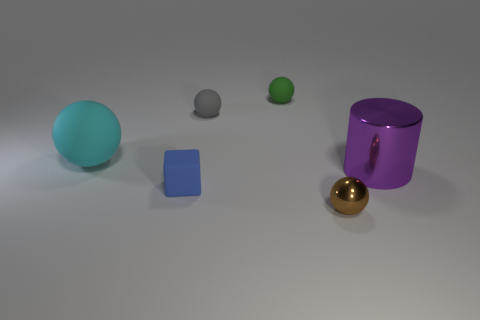Subtract all large spheres. How many spheres are left? 3 Add 2 yellow shiny blocks. How many objects exist? 8 Subtract all cyan spheres. How many spheres are left? 3 Subtract all cylinders. How many objects are left? 5 Subtract all cyan spheres. Subtract all purple cylinders. How many spheres are left? 3 Subtract all small gray rubber objects. Subtract all green spheres. How many objects are left? 4 Add 3 tiny green matte spheres. How many tiny green matte spheres are left? 4 Add 2 small blue matte cubes. How many small blue matte cubes exist? 3 Subtract 0 yellow cylinders. How many objects are left? 6 